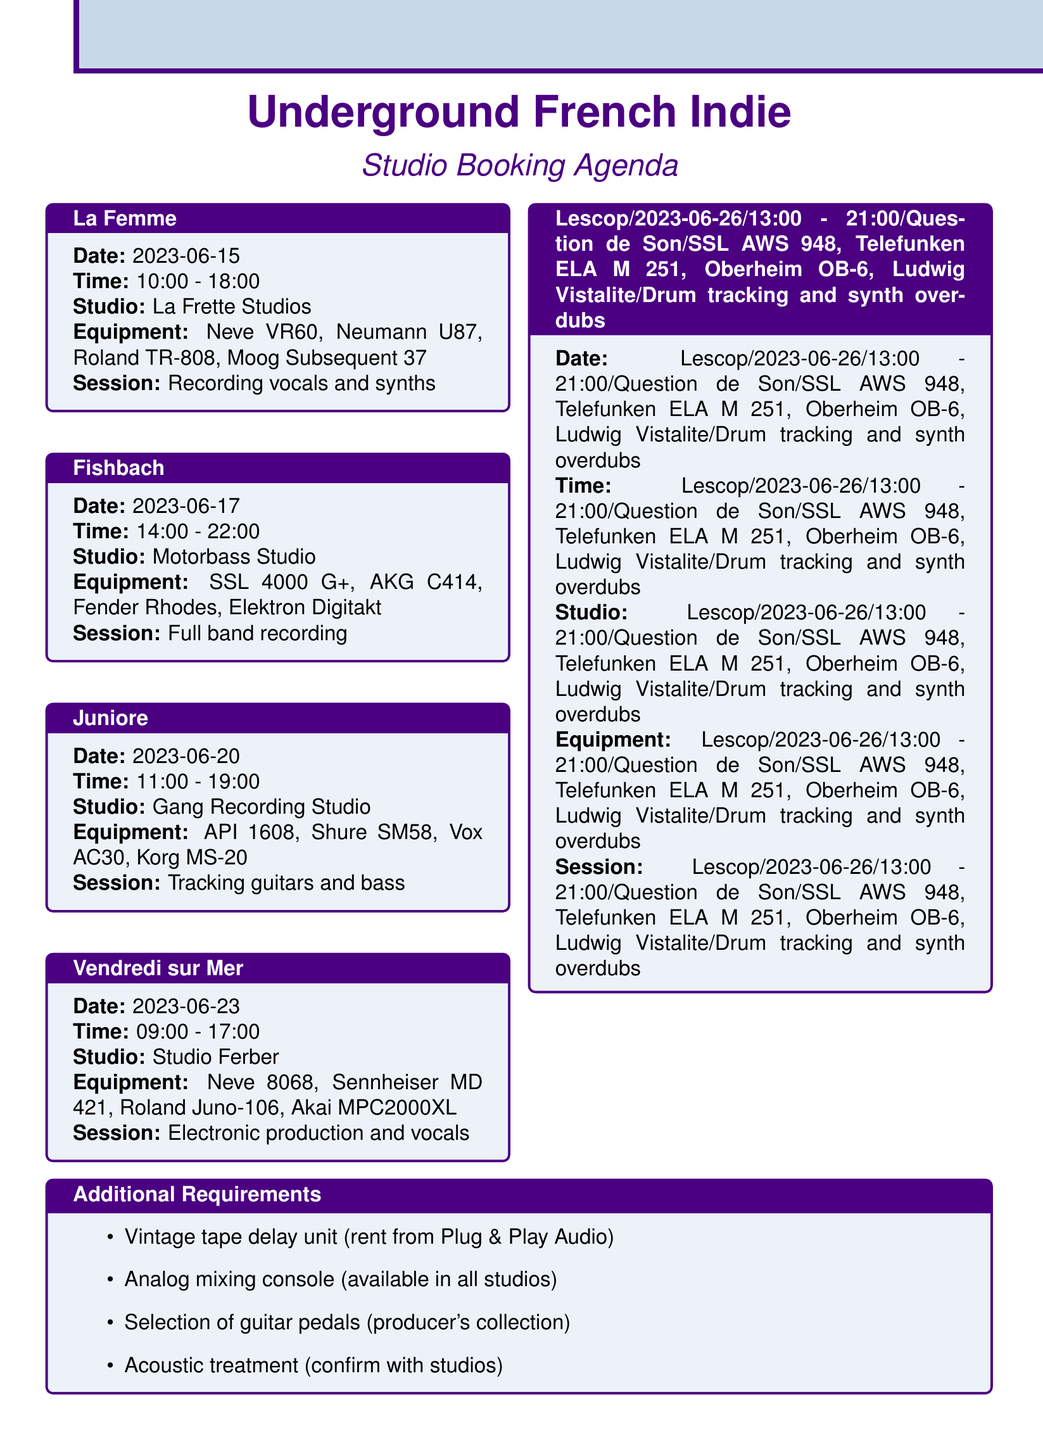What is the date of La Femme's session? La Femme's session is scheduled for June 15, 2023.
Answer: June 15, 2023 What equipment is used in the session with Juniore? The session with Juniore uses an API 1608 console, Shure SM58 microphones, Vox AC30 guitar amplifier, and Korg MS-20 synthesizer.
Answer: API 1608, Shure SM58, Vox AC30, Korg MS-20 What is the duration of the mixing task in post-production? The duration of the mixing task is specified as 2 weeks.
Answer: 2 weeks Which studio is booked for Fishbach's recording session? The studio booked for Fishbach's recording session is Motorbass Studio.
Answer: Motorbass Studio What is one of the additional requirements for recording sessions? One of the additional requirements is a vintage tape delay unit for creating atmospheric effects.
Answer: Vintage tape delay unit Who is the engineer for the mastering task? The engineer for the mastering task is mentioned as Chab Mastering.
Answer: Chab Mastering What time does the session with Lescop begin? The session with Lescop begins at 1:00 PM.
Answer: 1:00 PM How many microphones are listed for Vendredi sur Mer's session? Vendredi sur Mer's session lists four microphones: Sennheiser MD 421.
Answer: Four microphones What is the session type for La Femme's recording? The session type for La Femme's recording is focused on vocals and synths.
Answer: Recording vocals and synths 